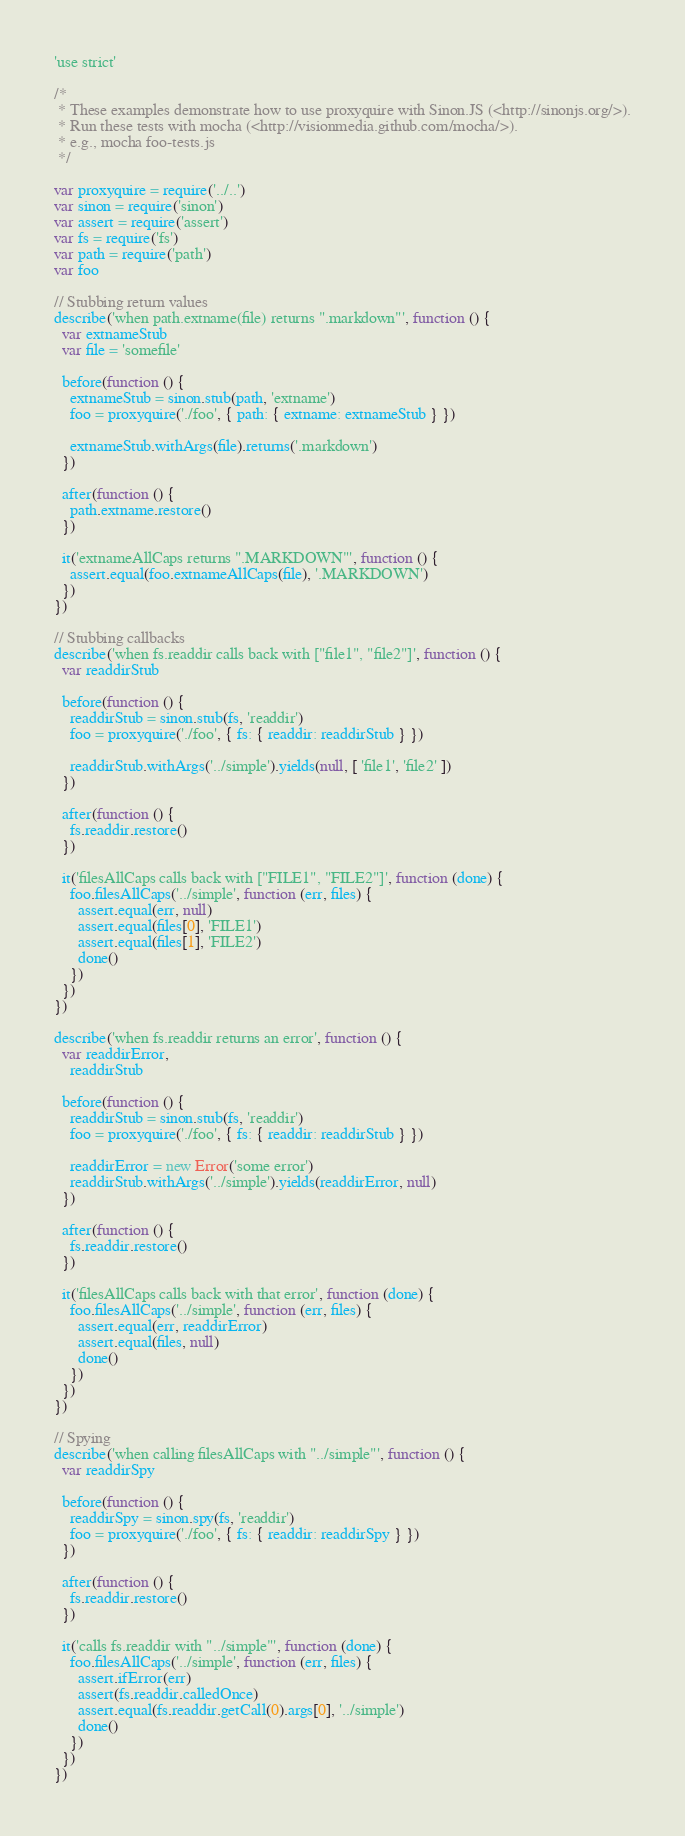<code> <loc_0><loc_0><loc_500><loc_500><_JavaScript_>'use strict'

/*
 * These examples demonstrate how to use proxyquire with Sinon.JS (<http://sinonjs.org/>).
 * Run these tests with mocha (<http://visionmedia.github.com/mocha/>).
 * e.g., mocha foo-tests.js
 */

var proxyquire = require('../..')
var sinon = require('sinon')
var assert = require('assert')
var fs = require('fs')
var path = require('path')
var foo

// Stubbing return values
describe('when path.extname(file) returns ".markdown"', function () {
  var extnameStub
  var file = 'somefile'

  before(function () {
    extnameStub = sinon.stub(path, 'extname')
    foo = proxyquire('./foo', { path: { extname: extnameStub } })

    extnameStub.withArgs(file).returns('.markdown')
  })

  after(function () {
    path.extname.restore()
  })

  it('extnameAllCaps returns ".MARKDOWN"', function () {
    assert.equal(foo.extnameAllCaps(file), '.MARKDOWN')
  })
})

// Stubbing callbacks
describe('when fs.readdir calls back with ["file1", "file2"]', function () {
  var readdirStub

  before(function () {
    readdirStub = sinon.stub(fs, 'readdir')
    foo = proxyquire('./foo', { fs: { readdir: readdirStub } })

    readdirStub.withArgs('../simple').yields(null, [ 'file1', 'file2' ])
  })

  after(function () {
    fs.readdir.restore()
  })

  it('filesAllCaps calls back with ["FILE1", "FILE2"]', function (done) {
    foo.filesAllCaps('../simple', function (err, files) {
      assert.equal(err, null)
      assert.equal(files[0], 'FILE1')
      assert.equal(files[1], 'FILE2')
      done()
    })
  })
})

describe('when fs.readdir returns an error', function () {
  var readdirError,
    readdirStub

  before(function () {
    readdirStub = sinon.stub(fs, 'readdir')
    foo = proxyquire('./foo', { fs: { readdir: readdirStub } })

    readdirError = new Error('some error')
    readdirStub.withArgs('../simple').yields(readdirError, null)
  })

  after(function () {
    fs.readdir.restore()
  })

  it('filesAllCaps calls back with that error', function (done) {
    foo.filesAllCaps('../simple', function (err, files) {
      assert.equal(err, readdirError)
      assert.equal(files, null)
      done()
    })
  })
})

// Spying
describe('when calling filesAllCaps with "../simple"', function () {
  var readdirSpy

  before(function () {
    readdirSpy = sinon.spy(fs, 'readdir')
    foo = proxyquire('./foo', { fs: { readdir: readdirSpy } })
  })

  after(function () {
    fs.readdir.restore()
  })

  it('calls fs.readdir with "../simple"', function (done) {
    foo.filesAllCaps('../simple', function (err, files) {
      assert.ifError(err)
      assert(fs.readdir.calledOnce)
      assert.equal(fs.readdir.getCall(0).args[0], '../simple')
      done()
    })
  })
})
</code> 